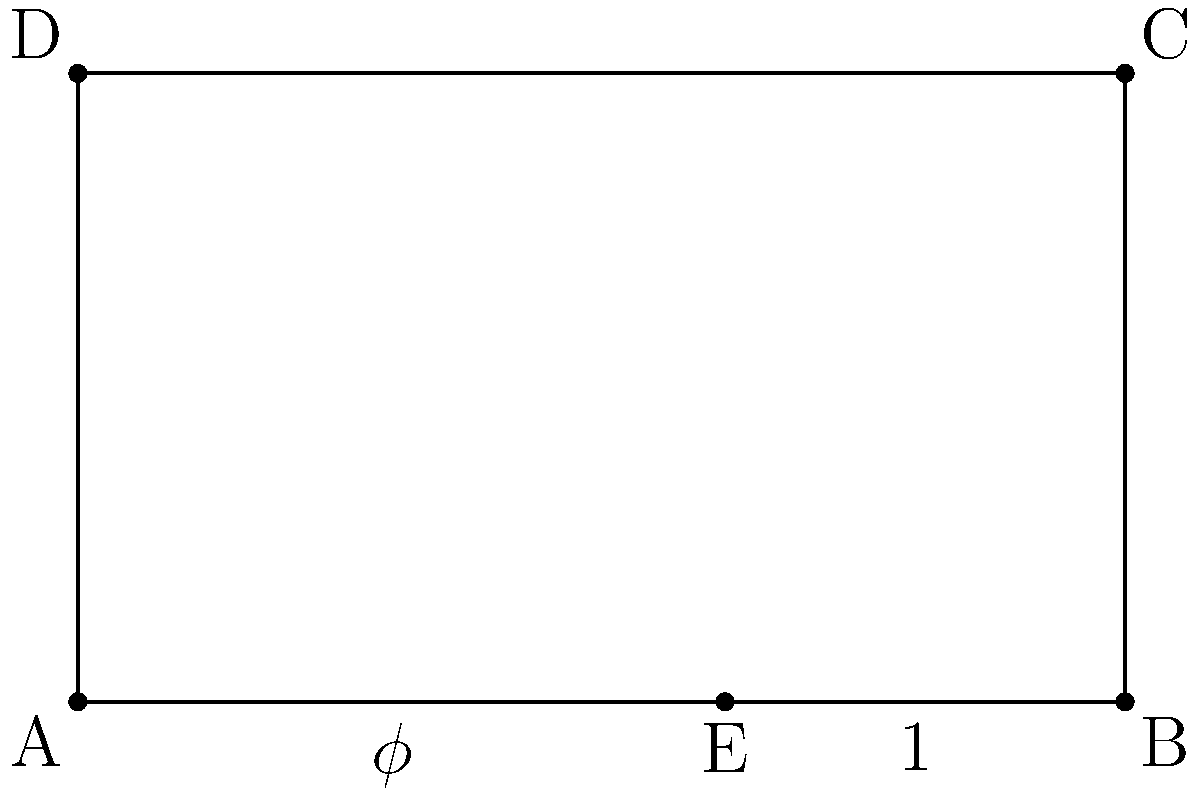In the diagram above, rectangle ABCD represents a religious painting incorporating the golden ratio. If AE:EB represents the golden ratio ($\phi$), and EB has a length of 1 unit, what is the approximate length of AB to two decimal places? To solve this problem, we'll follow these steps:

1) The golden ratio $\phi$ is defined as:
   $\phi = \frac{a+b}{a} = \frac{a}{b}$ where $a > b$

2) In our case, $AE = a$ and $EB = b = 1$

3) We can write: $\phi = \frac{AE + 1}{AE} = \frac{AE}{1}$

4) From this, we can derive: $AE = \phi$

5) The value of $\phi$ is approximately 1.618033988...

6) Since $AB = AE + EB = \phi + 1$

7) $AB \approx 1.618033988... + 1 = 2.618033988...$

8) Rounding to two decimal places, we get $AB \approx 2.62$

This incorporation of the golden ratio in religious art often symbolizes divine proportion and cosmic harmony, reflecting the theologian's interest in the intersection of cosmology and religious beliefs.
Answer: 2.62 